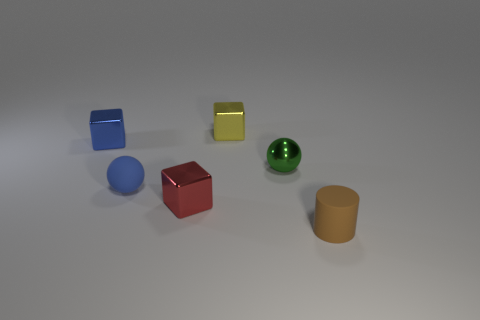What number of things are tiny metallic things behind the tiny green ball or small rubber things?
Your answer should be very brief. 4. There is another tiny object that is the same shape as the green thing; what color is it?
Offer a very short reply. Blue. Are there any other things of the same color as the tiny rubber sphere?
Offer a terse response. Yes. There is a matte sphere; does it have the same color as the block left of the tiny red thing?
Offer a very short reply. Yes. How many other objects are the same material as the small red thing?
Your answer should be compact. 3. Is the number of small gray shiny cylinders greater than the number of blue spheres?
Offer a very short reply. No. There is a tiny metal object that is left of the small red object; is its color the same as the tiny matte ball?
Offer a very short reply. Yes. What color is the small cylinder?
Your response must be concise. Brown. Is there a small red object behind the small ball that is on the left side of the tiny yellow cube?
Offer a very short reply. No. The metal object in front of the rubber object that is left of the brown rubber cylinder is what shape?
Give a very brief answer. Cube. 